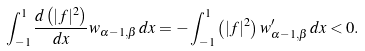<formula> <loc_0><loc_0><loc_500><loc_500>\int _ { - 1 } ^ { 1 } \frac { d \left ( | f | ^ { 2 } \right ) } { d x } w _ { \alpha - 1 , \beta } \, d x = - \int _ { - 1 } ^ { 1 } \left ( | f | ^ { 2 } \right ) w _ { \alpha - 1 , \beta } ^ { \prime } \, d x < 0 .</formula> 